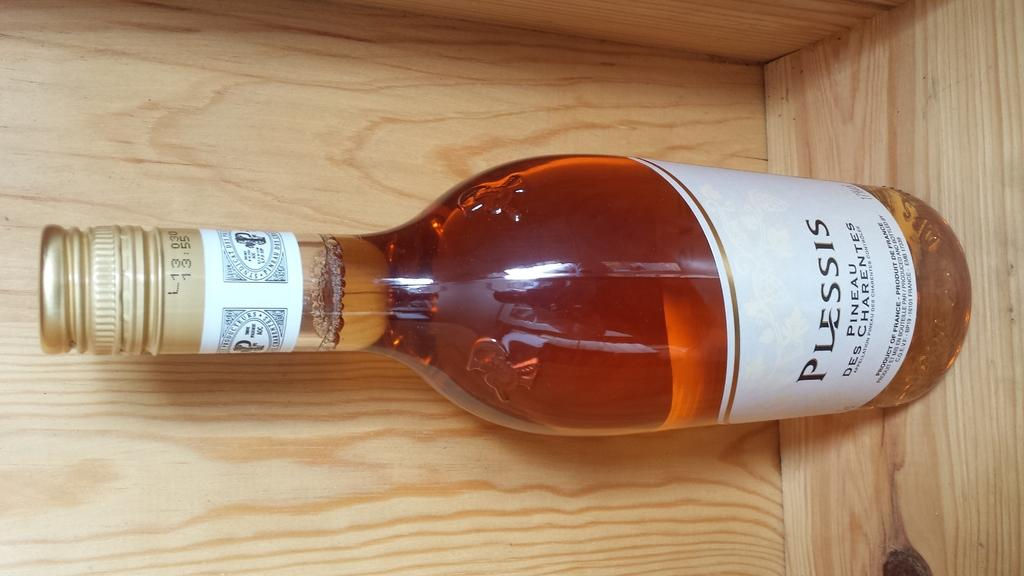<image>
Present a compact description of the photo's key features. The brand name of a wine bottle is Plessis. 